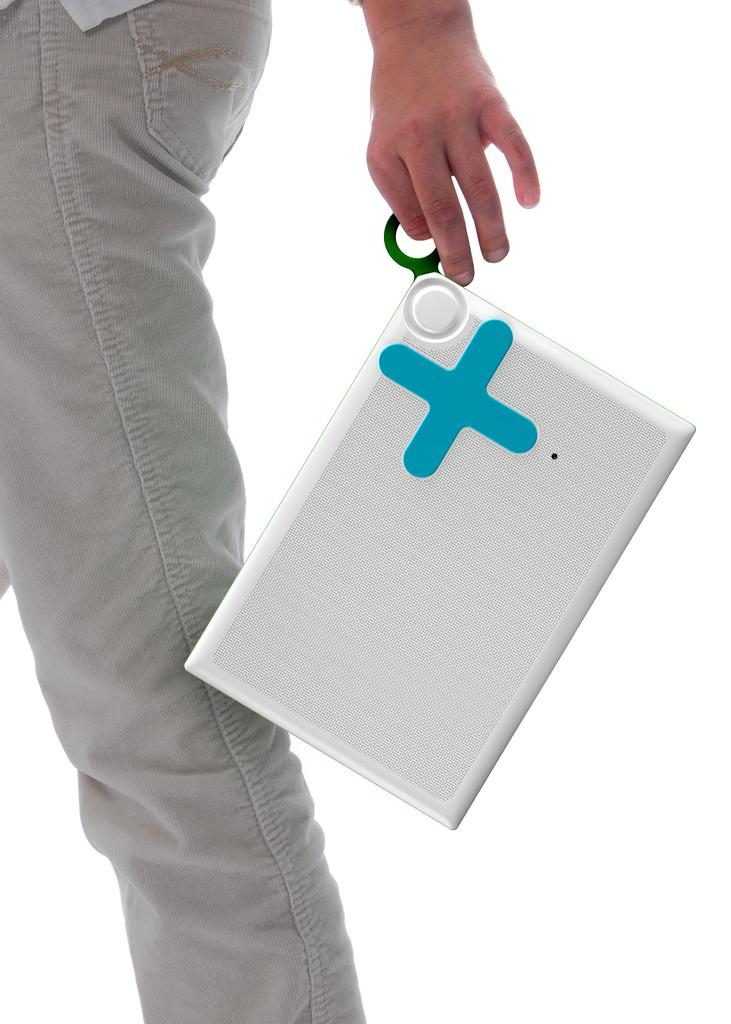What part of a person can be seen in the image? There is a leg of a person in the image. What is the person doing in the image? The person is holding an object. What type of tax is being discussed in the image? There is no discussion of tax in the image, as it only shows a leg of a person holding an object. 